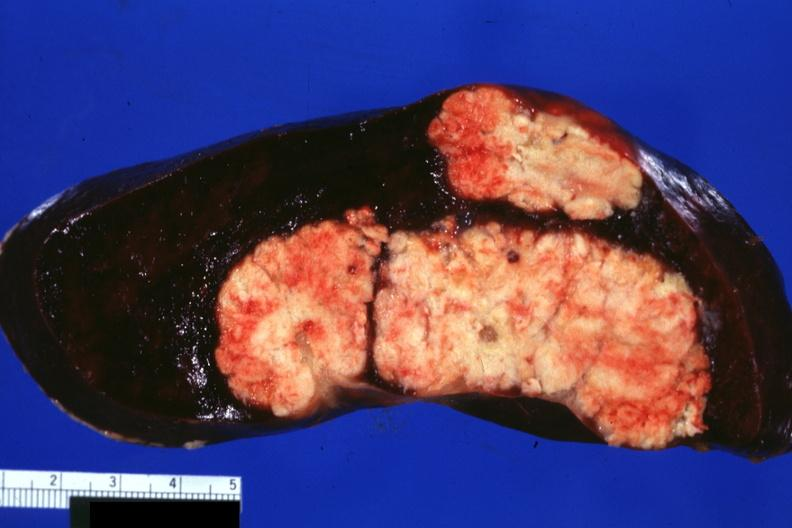s situs inversus present?
Answer the question using a single word or phrase. No 